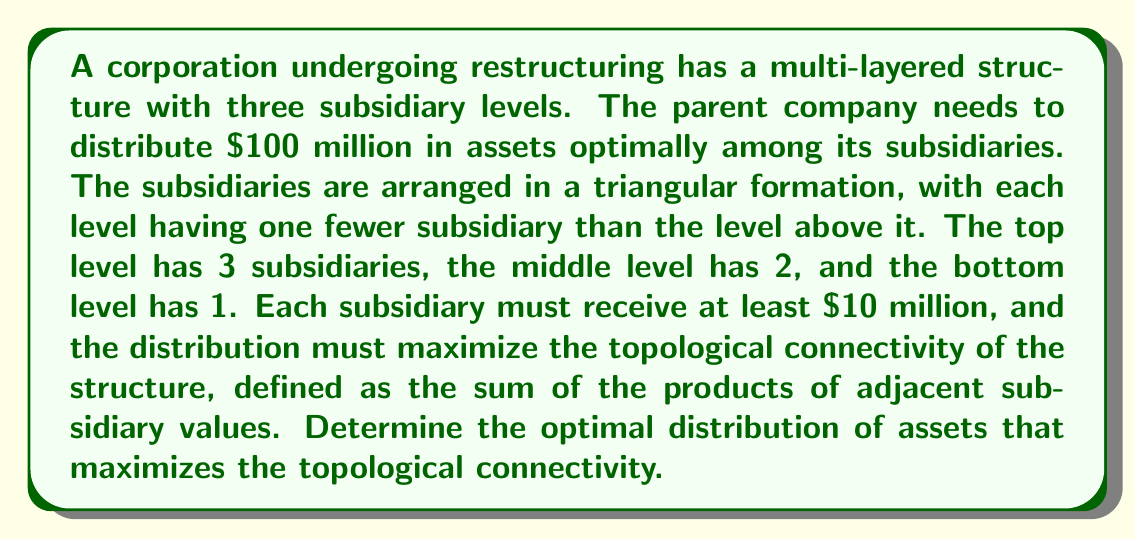Help me with this question. To solve this problem, we need to approach it step-by-step:

1) Let's denote the subsidiaries as follows:
   Top level: $a$, $b$, $c$
   Middle level: $d$, $e$
   Bottom level: $f$

2) The topological connectivity is defined as:
   $$(a\cdot d) + (a\cdot e) + (b\cdot d) + (b\cdot e) + (c\cdot e) + (d\cdot f) + (e\cdot f)$$

3) We need to maximize this value subject to the constraints:
   $$a + b + c + d + e + f = 100$$
   $$a, b, c, d, e, f \geq 10$$

4) This is a constrained optimization problem. The optimal solution will occur when the partial derivatives of the connectivity function with respect to each variable are equal (assuming interior solution).

5) Taking partial derivatives:
   $$\frac{\partial}{\partial a} = d + e$$
   $$\frac{\partial}{\partial b} = d + e$$
   $$\frac{\partial}{\partial c} = e$$
   $$\frac{\partial}{\partial d} = a + b + f$$
   $$\frac{\partial}{\partial e} = a + b + c + f$$
   $$\frac{\partial}{\partial f} = d + e$$

6) For optimality, these should be equal. We can see that $a$ and $b$ will be equal, and $d$ and $f$ will be equal.

7) Given the symmetry of the problem, the optimal solution will have $a = b > c$, $d = f$, and $e > d$.

8) Let $a = b = x$, $c = y$, $d = f = z$, and $e = w$. Then:
   $$2x + y + 2z + w = 100$$
   $$x + w = y + z$$
   $$2x + y = w$$

9) Solving this system of equations with the constraint that all variables ≥ 10:
   $x ≈ 21.67$, $y ≈ 16.67$, $z ≈ 15$, $w ≈ 25$

10) Rounding to the nearest million (as we're dealing with millions of dollars):
    $a = b = 22$, $c = 17$, $d = f = 15$, $e = 25$

This distribution maximizes the topological connectivity while satisfying all constraints.
Answer: The optimal distribution of assets is:
Top level: $22 million, $22 million, $17 million
Middle level: $15 million, $25 million
Bottom level: $15 million 